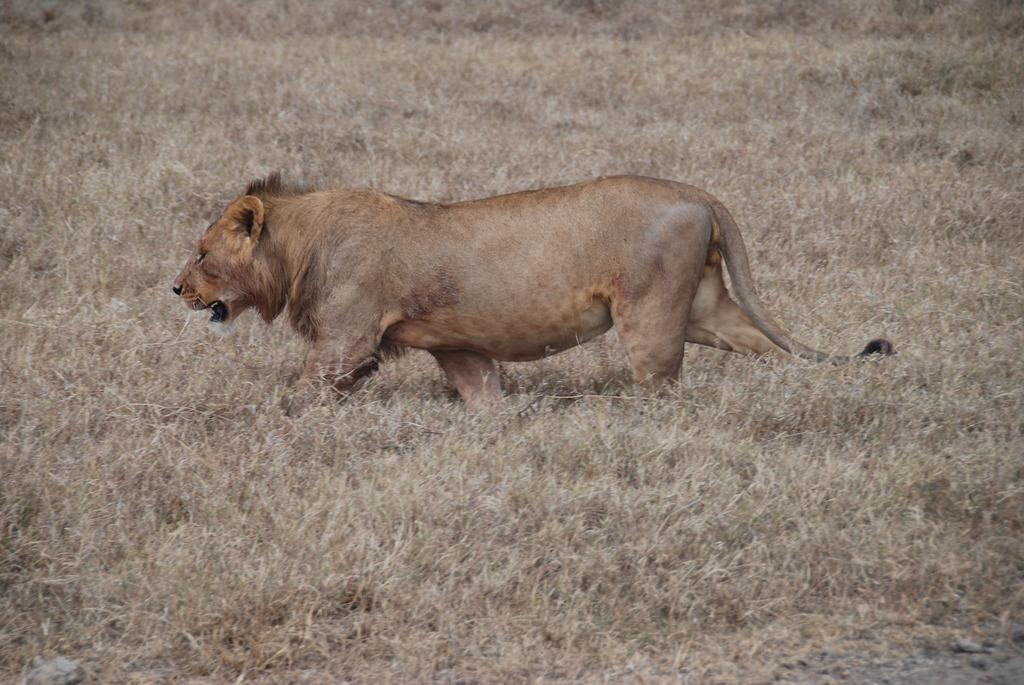What type of environment is depicted in the image? The image is an outside view. What type of vegetation is present on the ground in the image? There is grass on the ground in the image. What animal can be seen in the image? There is a lion in the image. In which direction is the lion moving? The lion is walking towards the left side of the image. What type of attraction is the lion pushing in the image? There is no attraction present in the image, and the lion is not pushing anything. What type of room is visible in the image? The image is an outside view, so there is no room visible in the image. 